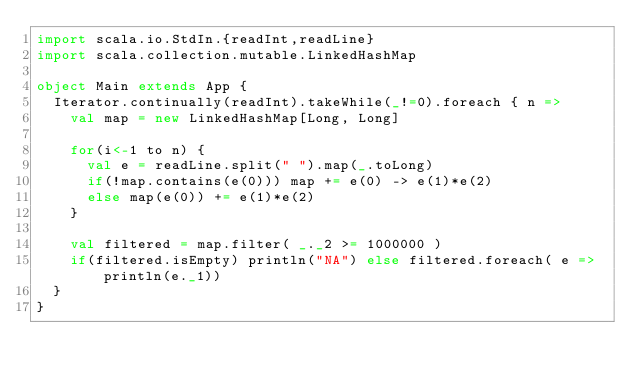<code> <loc_0><loc_0><loc_500><loc_500><_Scala_>import scala.io.StdIn.{readInt,readLine}
import scala.collection.mutable.LinkedHashMap

object Main extends App {
  Iterator.continually(readInt).takeWhile(_!=0).foreach { n =>
    val map = new LinkedHashMap[Long, Long]

    for(i<-1 to n) {
      val e = readLine.split(" ").map(_.toLong)
      if(!map.contains(e(0))) map += e(0) -> e(1)*e(2)
      else map(e(0)) += e(1)*e(2)
    }

    val filtered = map.filter( _._2 >= 1000000 )
    if(filtered.isEmpty) println("NA") else filtered.foreach( e => println(e._1))
  }
}</code> 